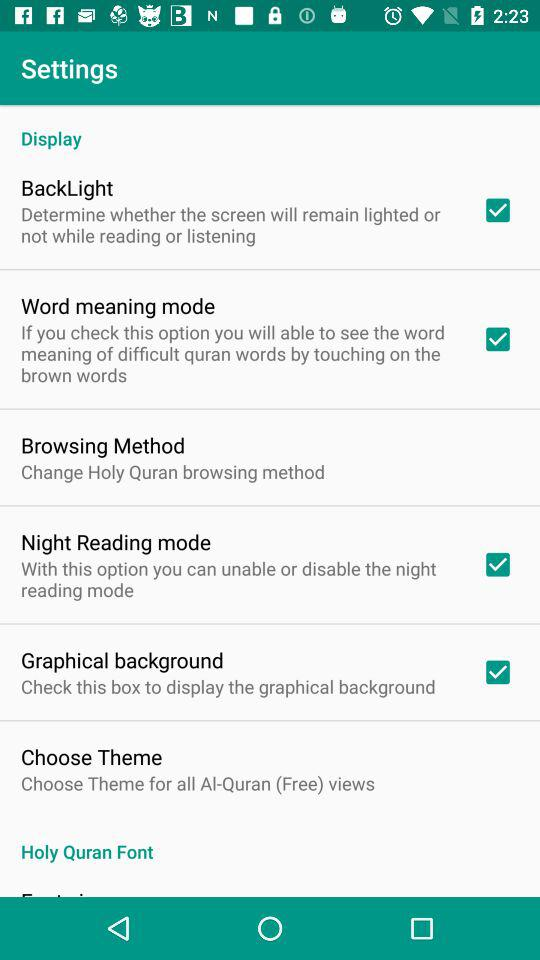Tell me more about the 'Choose Theme' option. The 'Choose Theme' option seems to allow users to customize the visual appearance of the app interface. While it's not checked, indicating that it's not active in this screenshot, users can likely select from various color schemes or designs to personalize their reading experience and make it more engaging or easier on the eyes. 